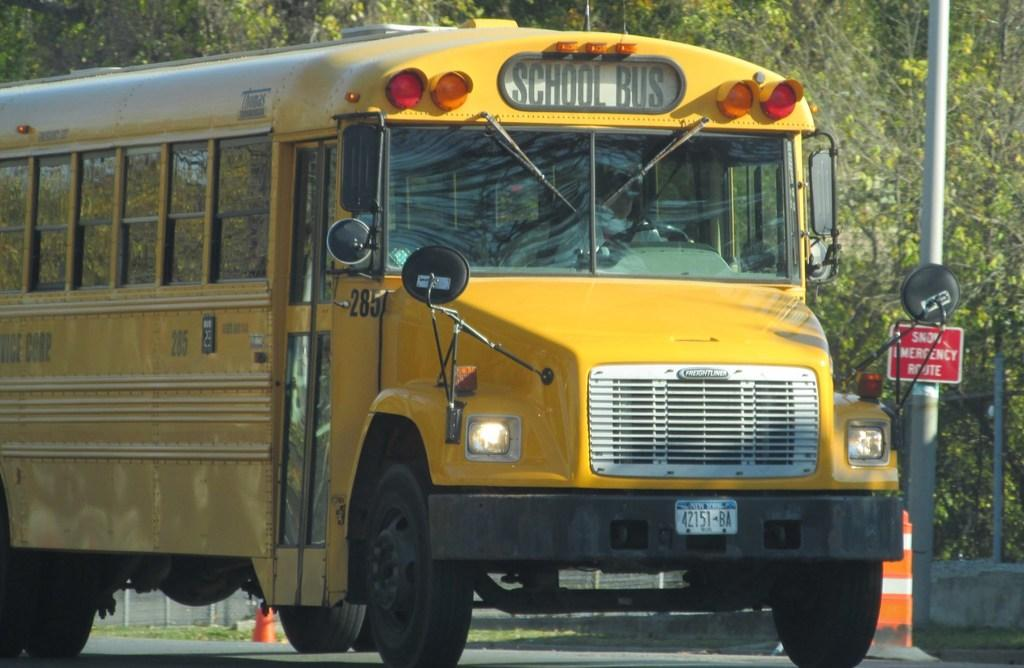<image>
Give a short and clear explanation of the subsequent image. Bus 285 has its headlights on as it drives downt he road. 